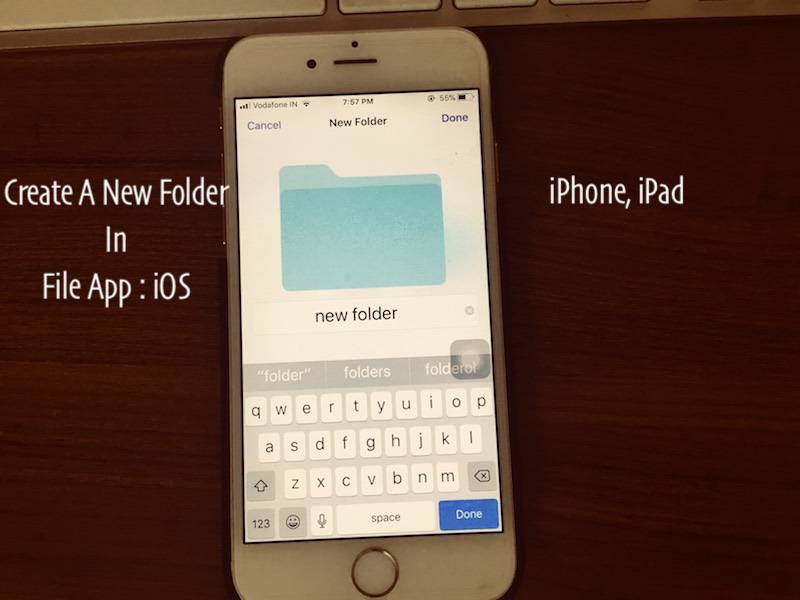Considering the battery percentage and time shown, what might be the user's next action after creating the new folder? Given that the battery is at 56% and it is 7:57 PM, the user might choose to either continue organizing their files or start preparing for the next day. This preparation could involve charging the device to ensure it's ready for use the following day. The user might also take this opportunity to review any other tasks for the evening, such as checking messages or setting reminders. 